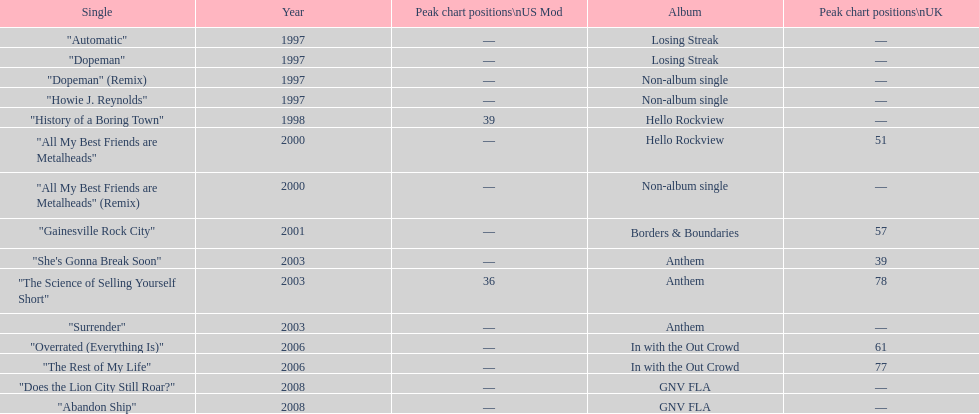Apart from "dopeman," what is one other single featured on the losing streak album? "Automatic". 